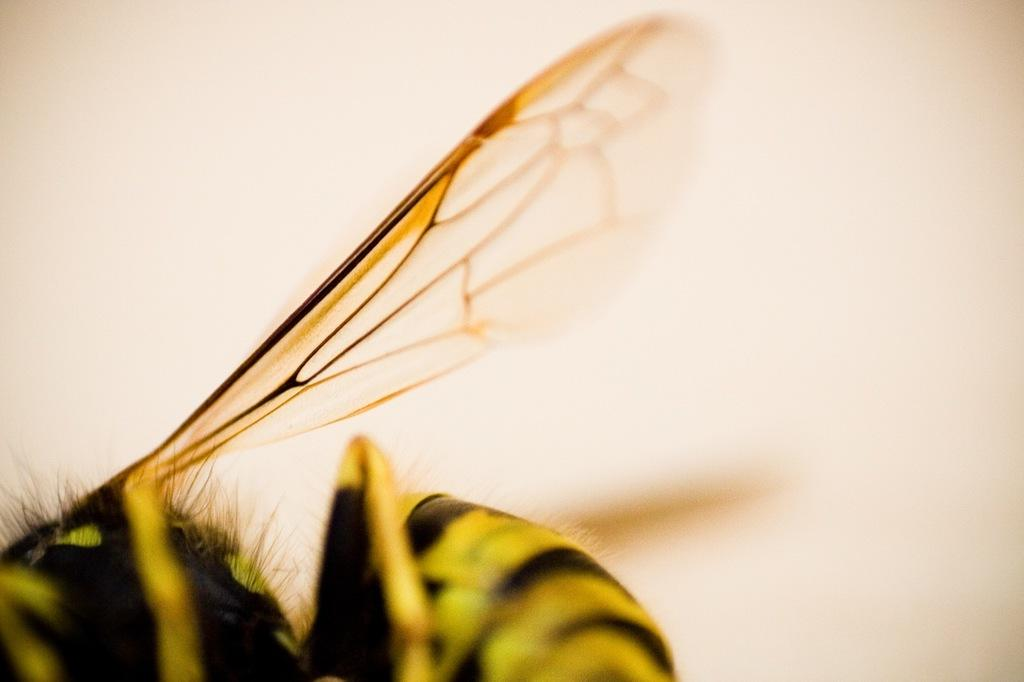What is the main subject of the image? There is a fly in the image. Can you describe the background of the image? The background of the image is blurry. What type of salt is being used in the science show in the image? There is no salt, science show, or any other objects or activities present in the image besides the fly. 